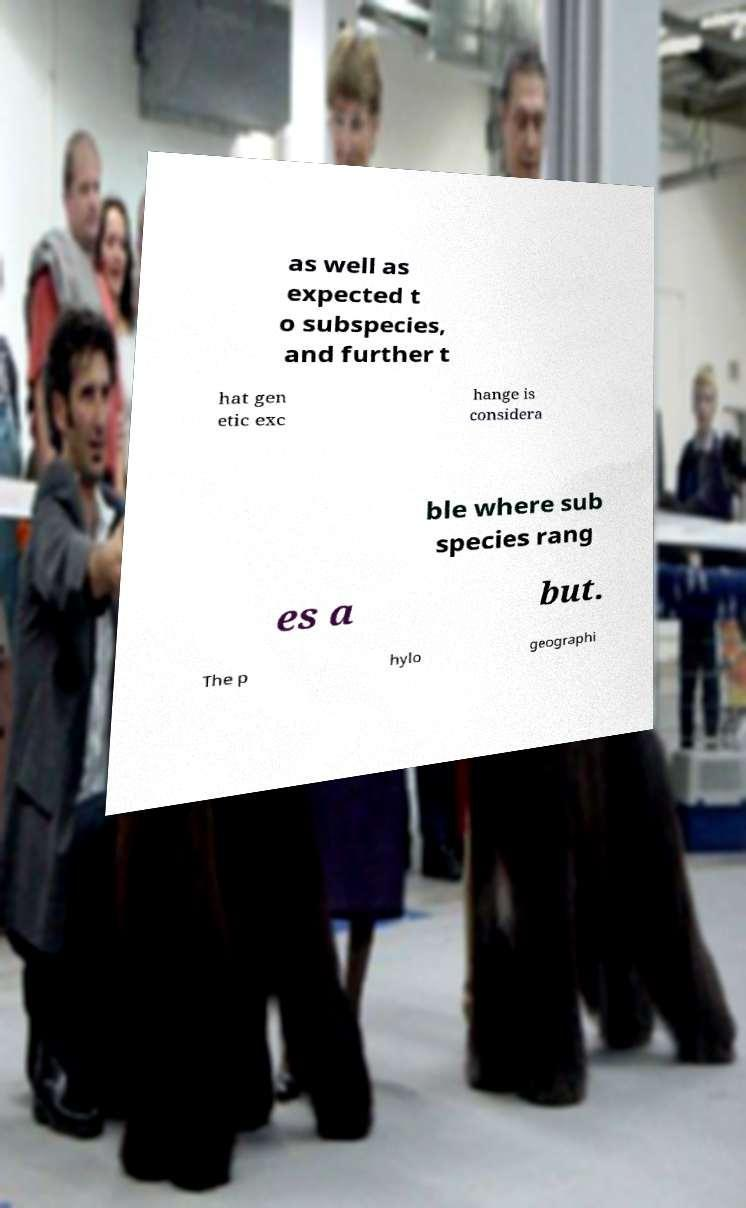Can you accurately transcribe the text from the provided image for me? as well as expected t o subspecies, and further t hat gen etic exc hange is considera ble where sub species rang es a but. The p hylo geographi 